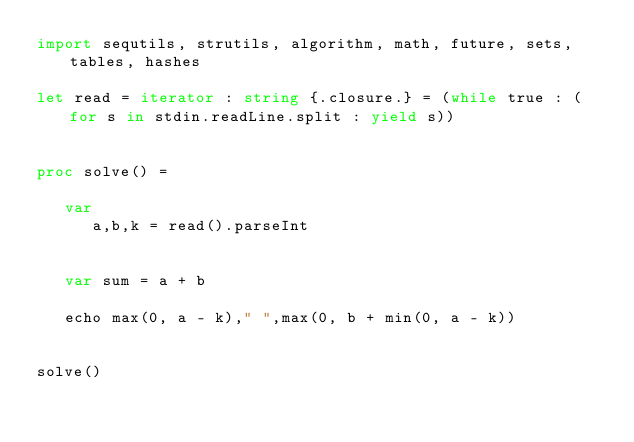<code> <loc_0><loc_0><loc_500><loc_500><_Nim_>import sequtils, strutils, algorithm, math, future, sets, tables, hashes

let read = iterator : string {.closure.} = (while true : (for s in stdin.readLine.split : yield s))


proc solve() =
   
   var
      a,b,k = read().parseInt 

      
   var sum = a + b

   echo max(0, a - k)," ",max(0, b + min(0, a - k))


solve()</code> 